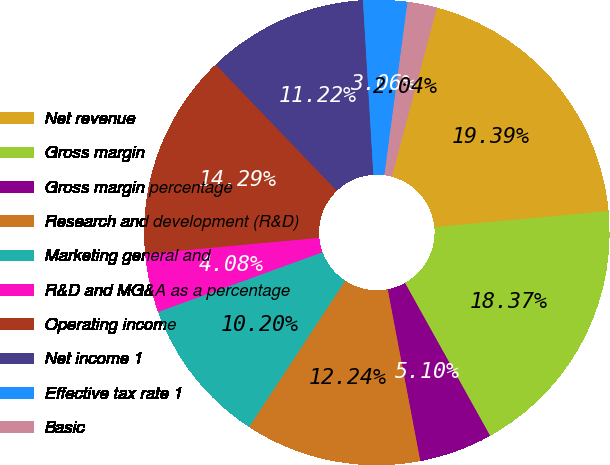<chart> <loc_0><loc_0><loc_500><loc_500><pie_chart><fcel>Net revenue<fcel>Gross margin<fcel>Gross margin percentage<fcel>Research and development (R&D)<fcel>Marketing general and<fcel>R&D and MG&A as a percentage<fcel>Operating income<fcel>Net income 1<fcel>Effective tax rate 1<fcel>Basic<nl><fcel>19.39%<fcel>18.37%<fcel>5.1%<fcel>12.24%<fcel>10.2%<fcel>4.08%<fcel>14.29%<fcel>11.22%<fcel>3.06%<fcel>2.04%<nl></chart> 